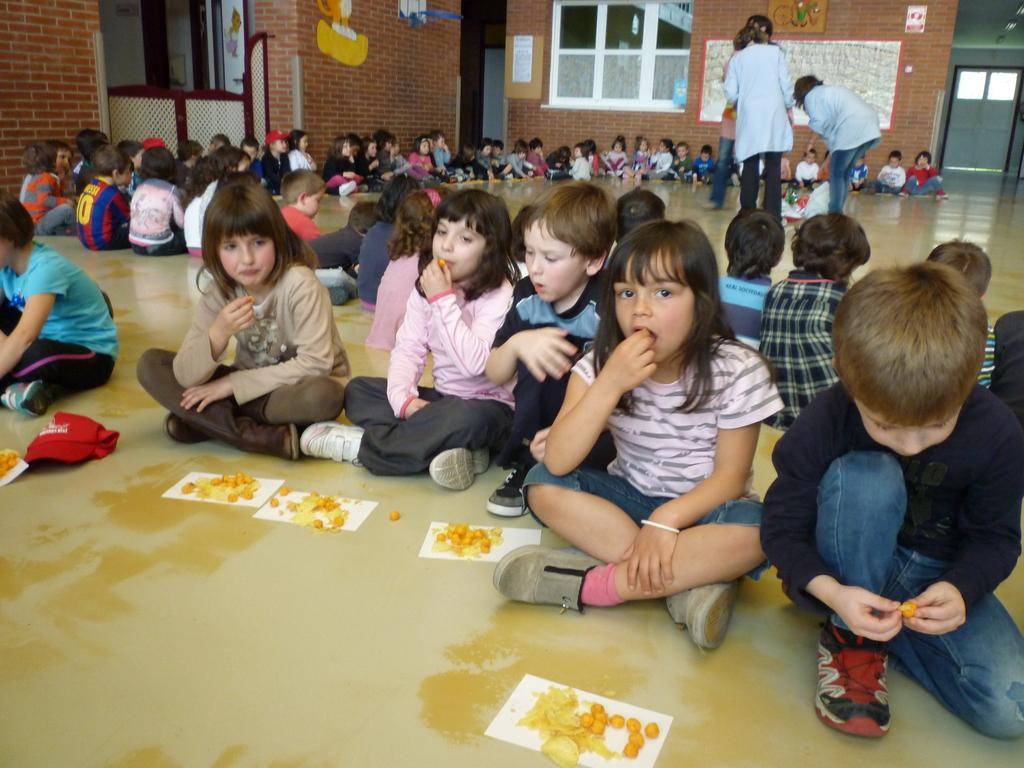Could you give a brief overview of what you see in this image? In this image we can see the kids sitting on the floor and having food. We can also see the persons standing in the background. We can also see the walls, windows and also posters attached to the wall. We can also see the door. At the bottom we can see the food items on the paper which is placed on the floor. 